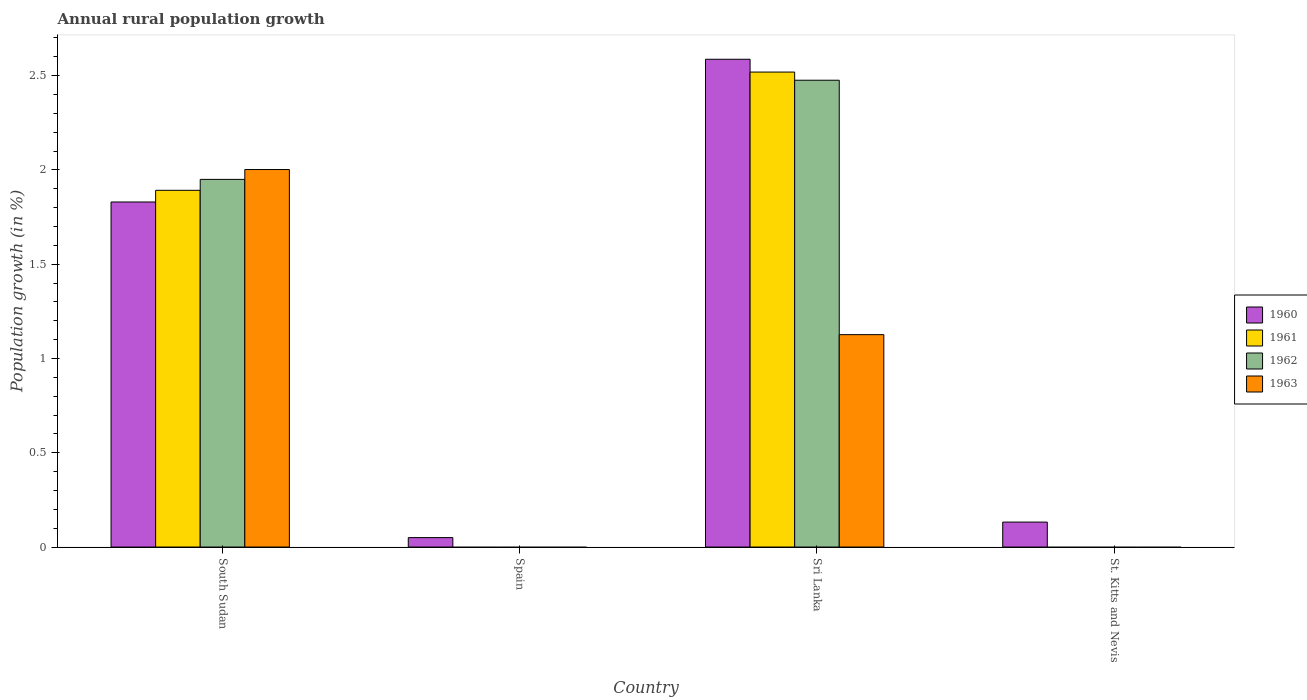Are the number of bars on each tick of the X-axis equal?
Your response must be concise. No. How many bars are there on the 3rd tick from the left?
Your answer should be very brief. 4. What is the label of the 3rd group of bars from the left?
Keep it short and to the point. Sri Lanka. What is the percentage of rural population growth in 1963 in Sri Lanka?
Your answer should be very brief. 1.13. Across all countries, what is the maximum percentage of rural population growth in 1960?
Offer a very short reply. 2.59. In which country was the percentage of rural population growth in 1963 maximum?
Give a very brief answer. South Sudan. What is the total percentage of rural population growth in 1962 in the graph?
Give a very brief answer. 4.43. What is the difference between the percentage of rural population growth in 1960 in St. Kitts and Nevis and the percentage of rural population growth in 1962 in Spain?
Ensure brevity in your answer.  0.13. What is the average percentage of rural population growth in 1962 per country?
Ensure brevity in your answer.  1.11. What is the difference between the percentage of rural population growth of/in 1961 and percentage of rural population growth of/in 1963 in Sri Lanka?
Your answer should be compact. 1.39. What is the ratio of the percentage of rural population growth in 1960 in Sri Lanka to that in St. Kitts and Nevis?
Ensure brevity in your answer.  19.54. Is the percentage of rural population growth in 1963 in South Sudan less than that in Sri Lanka?
Provide a short and direct response. No. What is the difference between the highest and the second highest percentage of rural population growth in 1960?
Your response must be concise. -1.7. What is the difference between the highest and the lowest percentage of rural population growth in 1961?
Ensure brevity in your answer.  2.52. Is it the case that in every country, the sum of the percentage of rural population growth in 1962 and percentage of rural population growth in 1960 is greater than the sum of percentage of rural population growth in 1963 and percentage of rural population growth in 1961?
Ensure brevity in your answer.  No. How many bars are there?
Offer a terse response. 10. Are all the bars in the graph horizontal?
Ensure brevity in your answer.  No. How many countries are there in the graph?
Provide a short and direct response. 4. Does the graph contain any zero values?
Keep it short and to the point. Yes. Does the graph contain grids?
Make the answer very short. No. How many legend labels are there?
Ensure brevity in your answer.  4. How are the legend labels stacked?
Provide a succinct answer. Vertical. What is the title of the graph?
Your answer should be very brief. Annual rural population growth. What is the label or title of the Y-axis?
Your response must be concise. Population growth (in %). What is the Population growth (in %) in 1960 in South Sudan?
Your answer should be very brief. 1.83. What is the Population growth (in %) in 1961 in South Sudan?
Your response must be concise. 1.89. What is the Population growth (in %) of 1962 in South Sudan?
Provide a short and direct response. 1.95. What is the Population growth (in %) of 1963 in South Sudan?
Your response must be concise. 2. What is the Population growth (in %) in 1960 in Spain?
Provide a short and direct response. 0.05. What is the Population growth (in %) of 1962 in Spain?
Ensure brevity in your answer.  0. What is the Population growth (in %) in 1963 in Spain?
Keep it short and to the point. 0. What is the Population growth (in %) in 1960 in Sri Lanka?
Give a very brief answer. 2.59. What is the Population growth (in %) in 1961 in Sri Lanka?
Your answer should be compact. 2.52. What is the Population growth (in %) of 1962 in Sri Lanka?
Give a very brief answer. 2.48. What is the Population growth (in %) in 1963 in Sri Lanka?
Make the answer very short. 1.13. What is the Population growth (in %) of 1960 in St. Kitts and Nevis?
Your response must be concise. 0.13. What is the Population growth (in %) of 1961 in St. Kitts and Nevis?
Provide a succinct answer. 0. What is the Population growth (in %) of 1962 in St. Kitts and Nevis?
Keep it short and to the point. 0. Across all countries, what is the maximum Population growth (in %) in 1960?
Provide a succinct answer. 2.59. Across all countries, what is the maximum Population growth (in %) in 1961?
Your response must be concise. 2.52. Across all countries, what is the maximum Population growth (in %) of 1962?
Your answer should be compact. 2.48. Across all countries, what is the maximum Population growth (in %) in 1963?
Offer a very short reply. 2. Across all countries, what is the minimum Population growth (in %) of 1960?
Keep it short and to the point. 0.05. Across all countries, what is the minimum Population growth (in %) of 1962?
Keep it short and to the point. 0. Across all countries, what is the minimum Population growth (in %) in 1963?
Make the answer very short. 0. What is the total Population growth (in %) in 1960 in the graph?
Give a very brief answer. 4.6. What is the total Population growth (in %) in 1961 in the graph?
Ensure brevity in your answer.  4.41. What is the total Population growth (in %) of 1962 in the graph?
Provide a succinct answer. 4.43. What is the total Population growth (in %) in 1963 in the graph?
Your response must be concise. 3.13. What is the difference between the Population growth (in %) of 1960 in South Sudan and that in Spain?
Your response must be concise. 1.78. What is the difference between the Population growth (in %) of 1960 in South Sudan and that in Sri Lanka?
Ensure brevity in your answer.  -0.76. What is the difference between the Population growth (in %) of 1961 in South Sudan and that in Sri Lanka?
Keep it short and to the point. -0.63. What is the difference between the Population growth (in %) of 1962 in South Sudan and that in Sri Lanka?
Ensure brevity in your answer.  -0.53. What is the difference between the Population growth (in %) of 1963 in South Sudan and that in Sri Lanka?
Your answer should be very brief. 0.88. What is the difference between the Population growth (in %) in 1960 in South Sudan and that in St. Kitts and Nevis?
Keep it short and to the point. 1.7. What is the difference between the Population growth (in %) of 1960 in Spain and that in Sri Lanka?
Your answer should be compact. -2.54. What is the difference between the Population growth (in %) in 1960 in Spain and that in St. Kitts and Nevis?
Your answer should be very brief. -0.08. What is the difference between the Population growth (in %) in 1960 in Sri Lanka and that in St. Kitts and Nevis?
Give a very brief answer. 2.45. What is the difference between the Population growth (in %) of 1960 in South Sudan and the Population growth (in %) of 1961 in Sri Lanka?
Provide a short and direct response. -0.69. What is the difference between the Population growth (in %) of 1960 in South Sudan and the Population growth (in %) of 1962 in Sri Lanka?
Your answer should be very brief. -0.65. What is the difference between the Population growth (in %) in 1960 in South Sudan and the Population growth (in %) in 1963 in Sri Lanka?
Provide a short and direct response. 0.7. What is the difference between the Population growth (in %) of 1961 in South Sudan and the Population growth (in %) of 1962 in Sri Lanka?
Give a very brief answer. -0.58. What is the difference between the Population growth (in %) of 1961 in South Sudan and the Population growth (in %) of 1963 in Sri Lanka?
Provide a succinct answer. 0.77. What is the difference between the Population growth (in %) in 1962 in South Sudan and the Population growth (in %) in 1963 in Sri Lanka?
Offer a very short reply. 0.82. What is the difference between the Population growth (in %) in 1960 in Spain and the Population growth (in %) in 1961 in Sri Lanka?
Offer a very short reply. -2.47. What is the difference between the Population growth (in %) of 1960 in Spain and the Population growth (in %) of 1962 in Sri Lanka?
Keep it short and to the point. -2.43. What is the difference between the Population growth (in %) of 1960 in Spain and the Population growth (in %) of 1963 in Sri Lanka?
Offer a very short reply. -1.08. What is the average Population growth (in %) in 1960 per country?
Keep it short and to the point. 1.15. What is the average Population growth (in %) of 1961 per country?
Your response must be concise. 1.1. What is the average Population growth (in %) of 1962 per country?
Your answer should be compact. 1.11. What is the average Population growth (in %) of 1963 per country?
Make the answer very short. 0.78. What is the difference between the Population growth (in %) in 1960 and Population growth (in %) in 1961 in South Sudan?
Your answer should be compact. -0.06. What is the difference between the Population growth (in %) of 1960 and Population growth (in %) of 1962 in South Sudan?
Make the answer very short. -0.12. What is the difference between the Population growth (in %) of 1960 and Population growth (in %) of 1963 in South Sudan?
Provide a succinct answer. -0.17. What is the difference between the Population growth (in %) in 1961 and Population growth (in %) in 1962 in South Sudan?
Offer a very short reply. -0.06. What is the difference between the Population growth (in %) in 1961 and Population growth (in %) in 1963 in South Sudan?
Provide a short and direct response. -0.11. What is the difference between the Population growth (in %) of 1962 and Population growth (in %) of 1963 in South Sudan?
Offer a terse response. -0.05. What is the difference between the Population growth (in %) of 1960 and Population growth (in %) of 1961 in Sri Lanka?
Provide a succinct answer. 0.07. What is the difference between the Population growth (in %) in 1960 and Population growth (in %) in 1962 in Sri Lanka?
Your answer should be compact. 0.11. What is the difference between the Population growth (in %) in 1960 and Population growth (in %) in 1963 in Sri Lanka?
Provide a succinct answer. 1.46. What is the difference between the Population growth (in %) in 1961 and Population growth (in %) in 1962 in Sri Lanka?
Offer a terse response. 0.04. What is the difference between the Population growth (in %) of 1961 and Population growth (in %) of 1963 in Sri Lanka?
Give a very brief answer. 1.39. What is the difference between the Population growth (in %) of 1962 and Population growth (in %) of 1963 in Sri Lanka?
Offer a very short reply. 1.35. What is the ratio of the Population growth (in %) in 1960 in South Sudan to that in Spain?
Your answer should be compact. 36.53. What is the ratio of the Population growth (in %) in 1960 in South Sudan to that in Sri Lanka?
Keep it short and to the point. 0.71. What is the ratio of the Population growth (in %) in 1961 in South Sudan to that in Sri Lanka?
Provide a succinct answer. 0.75. What is the ratio of the Population growth (in %) in 1962 in South Sudan to that in Sri Lanka?
Ensure brevity in your answer.  0.79. What is the ratio of the Population growth (in %) in 1963 in South Sudan to that in Sri Lanka?
Your answer should be compact. 1.78. What is the ratio of the Population growth (in %) in 1960 in South Sudan to that in St. Kitts and Nevis?
Make the answer very short. 13.82. What is the ratio of the Population growth (in %) of 1960 in Spain to that in Sri Lanka?
Your answer should be very brief. 0.02. What is the ratio of the Population growth (in %) in 1960 in Spain to that in St. Kitts and Nevis?
Keep it short and to the point. 0.38. What is the ratio of the Population growth (in %) of 1960 in Sri Lanka to that in St. Kitts and Nevis?
Make the answer very short. 19.54. What is the difference between the highest and the second highest Population growth (in %) in 1960?
Give a very brief answer. 0.76. What is the difference between the highest and the lowest Population growth (in %) of 1960?
Keep it short and to the point. 2.54. What is the difference between the highest and the lowest Population growth (in %) of 1961?
Provide a short and direct response. 2.52. What is the difference between the highest and the lowest Population growth (in %) in 1962?
Keep it short and to the point. 2.48. What is the difference between the highest and the lowest Population growth (in %) of 1963?
Your answer should be compact. 2. 